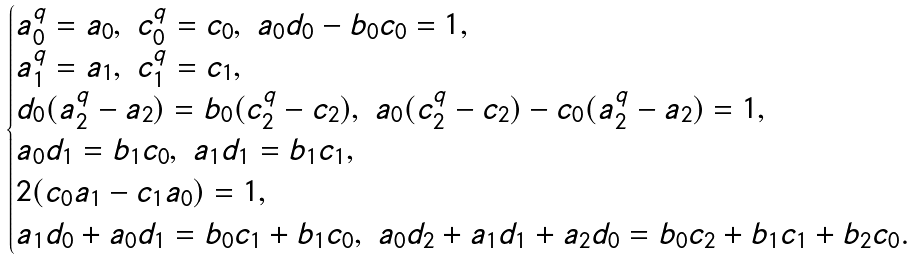<formula> <loc_0><loc_0><loc_500><loc_500>\begin{cases} a _ { 0 } ^ { q } = a _ { 0 } , \ c _ { 0 } ^ { q } = c _ { 0 } , \ a _ { 0 } d _ { 0 } - b _ { 0 } c _ { 0 } = 1 , \\ a _ { 1 } ^ { q } = a _ { 1 } , \ c _ { 1 } ^ { q } = c _ { 1 } , \ \\ d _ { 0 } ( a _ { 2 } ^ { q } - a _ { 2 } ) = b _ { 0 } ( c _ { 2 } ^ { q } - c _ { 2 } ) , \ a _ { 0 } ( c _ { 2 } ^ { q } - c _ { 2 } ) - c _ { 0 } ( a _ { 2 } ^ { q } - a _ { 2 } ) = 1 , \\ a _ { 0 } d _ { 1 } = b _ { 1 } c _ { 0 } , \ a _ { 1 } d _ { 1 } = b _ { 1 } c _ { 1 } , \\ 2 ( c _ { 0 } a _ { 1 } - c _ { 1 } a _ { 0 } ) = 1 , \\ a _ { 1 } d _ { 0 } + a _ { 0 } d _ { 1 } = b _ { 0 } c _ { 1 } + b _ { 1 } c _ { 0 } , \ a _ { 0 } d _ { 2 } + a _ { 1 } d _ { 1 } + a _ { 2 } d _ { 0 } = b _ { 0 } c _ { 2 } + b _ { 1 } c _ { 1 } + b _ { 2 } c _ { 0 } . \end{cases}</formula> 